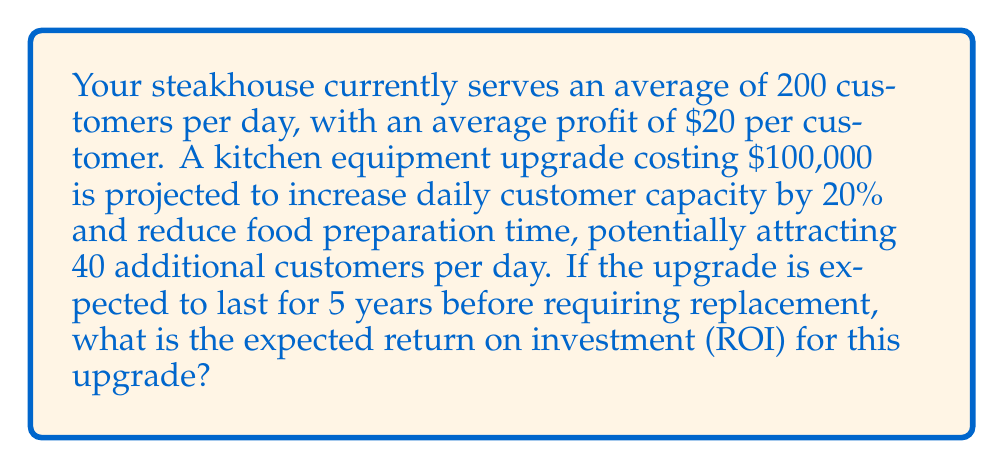Provide a solution to this math problem. Let's break this problem down step-by-step:

1. Calculate current daily profit:
   $200 \text{ customers} \times \$20 \text{ profit per customer} = \$4,000 \text{ daily profit}$

2. Calculate potential new daily profit:
   $240 \text{ customers} \times \$20 \text{ profit per customer} = \$4,800 \text{ daily profit}$

3. Calculate daily profit increase:
   $\$4,800 - \$4,000 = \$800 \text{ additional daily profit}$

4. Calculate annual profit increase:
   Assuming 365 days of operation:
   $\$800 \times 365 \text{ days} = \$292,000 \text{ annual profit increase}$

5. Calculate total profit increase over 5 years:
   $\$292,000 \times 5 \text{ years} = \$1,460,000 \text{ total profit increase}$

6. Calculate net profit:
   $\$1,460,000 - \$100,000 \text{ (cost of upgrade)} = \$1,360,000 \text{ net profit}$

7. Calculate ROI:
   ROI is typically expressed as a percentage and calculated as:
   $$\text{ROI} = \frac{\text{Net Profit}}{\text{Cost of Investment}} \times 100\%$$

   $$\text{ROI} = \frac{\$1,360,000}{\$100,000} \times 100\% = 1,360\%$$
Answer: The expected return on investment (ROI) for the kitchen equipment upgrade is 1,360%. 